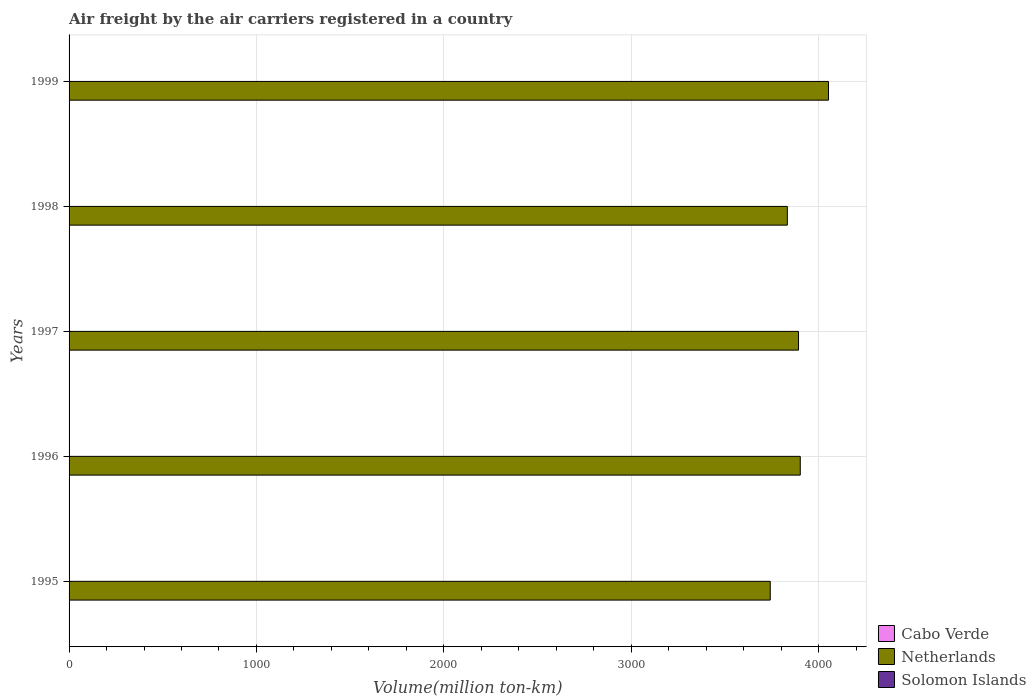How many different coloured bars are there?
Offer a terse response. 3. How many groups of bars are there?
Offer a very short reply. 5. Are the number of bars per tick equal to the number of legend labels?
Your response must be concise. Yes. Are the number of bars on each tick of the Y-axis equal?
Your answer should be very brief. Yes. How many bars are there on the 5th tick from the top?
Your answer should be compact. 3. What is the volume of the air carriers in Netherlands in 1996?
Keep it short and to the point. 3902.4. Across all years, what is the maximum volume of the air carriers in Netherlands?
Offer a terse response. 4053. Across all years, what is the minimum volume of the air carriers in Solomon Islands?
Your answer should be compact. 1.3. In which year was the volume of the air carriers in Solomon Islands minimum?
Provide a succinct answer. 1999. What is the total volume of the air carriers in Cabo Verde in the graph?
Offer a very short reply. 3.2. What is the difference between the volume of the air carriers in Solomon Islands in 1995 and that in 1996?
Offer a very short reply. -0.1. What is the difference between the volume of the air carriers in Netherlands in 1998 and the volume of the air carriers in Cabo Verde in 1999?
Give a very brief answer. 3832.8. What is the average volume of the air carriers in Netherlands per year?
Your response must be concise. 3884.82. In the year 1999, what is the difference between the volume of the air carriers in Solomon Islands and volume of the air carriers in Cabo Verde?
Provide a succinct answer. 0.7. In how many years, is the volume of the air carriers in Solomon Islands greater than 800 million ton-km?
Provide a succinct answer. 0. What is the ratio of the volume of the air carriers in Solomon Islands in 1996 to that in 1998?
Your answer should be compact. 1. Is the difference between the volume of the air carriers in Solomon Islands in 1997 and 1998 greater than the difference between the volume of the air carriers in Cabo Verde in 1997 and 1998?
Offer a terse response. No. What is the difference between the highest and the second highest volume of the air carriers in Netherlands?
Your answer should be compact. 150.6. What is the difference between the highest and the lowest volume of the air carriers in Solomon Islands?
Keep it short and to the point. 0.4. Is the sum of the volume of the air carriers in Netherlands in 1996 and 1998 greater than the maximum volume of the air carriers in Solomon Islands across all years?
Your answer should be very brief. Yes. What does the 2nd bar from the top in 1996 represents?
Give a very brief answer. Netherlands. What does the 2nd bar from the bottom in 1998 represents?
Your answer should be compact. Netherlands. Is it the case that in every year, the sum of the volume of the air carriers in Solomon Islands and volume of the air carriers in Netherlands is greater than the volume of the air carriers in Cabo Verde?
Ensure brevity in your answer.  Yes. What is the title of the graph?
Your response must be concise. Air freight by the air carriers registered in a country. What is the label or title of the X-axis?
Your response must be concise. Volume(million ton-km). What is the label or title of the Y-axis?
Offer a very short reply. Years. What is the Volume(million ton-km) in Cabo Verde in 1995?
Your answer should be compact. 0.8. What is the Volume(million ton-km) in Netherlands in 1995?
Give a very brief answer. 3742.2. What is the Volume(million ton-km) of Solomon Islands in 1995?
Offer a terse response. 1.6. What is the Volume(million ton-km) of Cabo Verde in 1996?
Your answer should be compact. 0.8. What is the Volume(million ton-km) in Netherlands in 1996?
Offer a terse response. 3902.4. What is the Volume(million ton-km) of Solomon Islands in 1996?
Provide a succinct answer. 1.7. What is the Volume(million ton-km) in Cabo Verde in 1997?
Provide a short and direct response. 0.6. What is the Volume(million ton-km) in Netherlands in 1997?
Provide a succinct answer. 3893.1. What is the Volume(million ton-km) in Solomon Islands in 1997?
Your response must be concise. 1.7. What is the Volume(million ton-km) of Cabo Verde in 1998?
Keep it short and to the point. 0.4. What is the Volume(million ton-km) of Netherlands in 1998?
Your answer should be very brief. 3833.4. What is the Volume(million ton-km) in Solomon Islands in 1998?
Provide a short and direct response. 1.7. What is the Volume(million ton-km) in Cabo Verde in 1999?
Provide a succinct answer. 0.6. What is the Volume(million ton-km) in Netherlands in 1999?
Make the answer very short. 4053. What is the Volume(million ton-km) of Solomon Islands in 1999?
Offer a terse response. 1.3. Across all years, what is the maximum Volume(million ton-km) in Cabo Verde?
Your response must be concise. 0.8. Across all years, what is the maximum Volume(million ton-km) in Netherlands?
Provide a short and direct response. 4053. Across all years, what is the maximum Volume(million ton-km) in Solomon Islands?
Keep it short and to the point. 1.7. Across all years, what is the minimum Volume(million ton-km) of Cabo Verde?
Provide a short and direct response. 0.4. Across all years, what is the minimum Volume(million ton-km) of Netherlands?
Offer a terse response. 3742.2. Across all years, what is the minimum Volume(million ton-km) in Solomon Islands?
Your answer should be very brief. 1.3. What is the total Volume(million ton-km) of Netherlands in the graph?
Your answer should be very brief. 1.94e+04. What is the difference between the Volume(million ton-km) of Netherlands in 1995 and that in 1996?
Give a very brief answer. -160.2. What is the difference between the Volume(million ton-km) of Netherlands in 1995 and that in 1997?
Offer a terse response. -150.9. What is the difference between the Volume(million ton-km) of Netherlands in 1995 and that in 1998?
Make the answer very short. -91.2. What is the difference between the Volume(million ton-km) of Solomon Islands in 1995 and that in 1998?
Your answer should be very brief. -0.1. What is the difference between the Volume(million ton-km) in Cabo Verde in 1995 and that in 1999?
Your response must be concise. 0.2. What is the difference between the Volume(million ton-km) of Netherlands in 1995 and that in 1999?
Keep it short and to the point. -310.8. What is the difference between the Volume(million ton-km) of Solomon Islands in 1995 and that in 1999?
Keep it short and to the point. 0.3. What is the difference between the Volume(million ton-km) of Netherlands in 1996 and that in 1997?
Make the answer very short. 9.3. What is the difference between the Volume(million ton-km) in Solomon Islands in 1996 and that in 1997?
Your answer should be very brief. 0. What is the difference between the Volume(million ton-km) in Netherlands in 1996 and that in 1999?
Offer a very short reply. -150.6. What is the difference between the Volume(million ton-km) of Cabo Verde in 1997 and that in 1998?
Provide a succinct answer. 0.2. What is the difference between the Volume(million ton-km) of Netherlands in 1997 and that in 1998?
Provide a short and direct response. 59.7. What is the difference between the Volume(million ton-km) in Solomon Islands in 1997 and that in 1998?
Provide a short and direct response. 0. What is the difference between the Volume(million ton-km) of Netherlands in 1997 and that in 1999?
Keep it short and to the point. -159.9. What is the difference between the Volume(million ton-km) in Netherlands in 1998 and that in 1999?
Keep it short and to the point. -219.6. What is the difference between the Volume(million ton-km) of Solomon Islands in 1998 and that in 1999?
Make the answer very short. 0.4. What is the difference between the Volume(million ton-km) of Cabo Verde in 1995 and the Volume(million ton-km) of Netherlands in 1996?
Provide a succinct answer. -3901.6. What is the difference between the Volume(million ton-km) of Cabo Verde in 1995 and the Volume(million ton-km) of Solomon Islands in 1996?
Provide a short and direct response. -0.9. What is the difference between the Volume(million ton-km) in Netherlands in 1995 and the Volume(million ton-km) in Solomon Islands in 1996?
Offer a very short reply. 3740.5. What is the difference between the Volume(million ton-km) of Cabo Verde in 1995 and the Volume(million ton-km) of Netherlands in 1997?
Offer a very short reply. -3892.3. What is the difference between the Volume(million ton-km) of Cabo Verde in 1995 and the Volume(million ton-km) of Solomon Islands in 1997?
Your answer should be compact. -0.9. What is the difference between the Volume(million ton-km) in Netherlands in 1995 and the Volume(million ton-km) in Solomon Islands in 1997?
Make the answer very short. 3740.5. What is the difference between the Volume(million ton-km) of Cabo Verde in 1995 and the Volume(million ton-km) of Netherlands in 1998?
Give a very brief answer. -3832.6. What is the difference between the Volume(million ton-km) of Cabo Verde in 1995 and the Volume(million ton-km) of Solomon Islands in 1998?
Offer a terse response. -0.9. What is the difference between the Volume(million ton-km) of Netherlands in 1995 and the Volume(million ton-km) of Solomon Islands in 1998?
Provide a short and direct response. 3740.5. What is the difference between the Volume(million ton-km) in Cabo Verde in 1995 and the Volume(million ton-km) in Netherlands in 1999?
Give a very brief answer. -4052.2. What is the difference between the Volume(million ton-km) of Cabo Verde in 1995 and the Volume(million ton-km) of Solomon Islands in 1999?
Offer a very short reply. -0.5. What is the difference between the Volume(million ton-km) of Netherlands in 1995 and the Volume(million ton-km) of Solomon Islands in 1999?
Give a very brief answer. 3740.9. What is the difference between the Volume(million ton-km) of Cabo Verde in 1996 and the Volume(million ton-km) of Netherlands in 1997?
Ensure brevity in your answer.  -3892.3. What is the difference between the Volume(million ton-km) of Netherlands in 1996 and the Volume(million ton-km) of Solomon Islands in 1997?
Give a very brief answer. 3900.7. What is the difference between the Volume(million ton-km) in Cabo Verde in 1996 and the Volume(million ton-km) in Netherlands in 1998?
Offer a very short reply. -3832.6. What is the difference between the Volume(million ton-km) in Netherlands in 1996 and the Volume(million ton-km) in Solomon Islands in 1998?
Ensure brevity in your answer.  3900.7. What is the difference between the Volume(million ton-km) of Cabo Verde in 1996 and the Volume(million ton-km) of Netherlands in 1999?
Provide a succinct answer. -4052.2. What is the difference between the Volume(million ton-km) of Netherlands in 1996 and the Volume(million ton-km) of Solomon Islands in 1999?
Provide a succinct answer. 3901.1. What is the difference between the Volume(million ton-km) of Cabo Verde in 1997 and the Volume(million ton-km) of Netherlands in 1998?
Provide a succinct answer. -3832.8. What is the difference between the Volume(million ton-km) in Cabo Verde in 1997 and the Volume(million ton-km) in Solomon Islands in 1998?
Offer a very short reply. -1.1. What is the difference between the Volume(million ton-km) in Netherlands in 1997 and the Volume(million ton-km) in Solomon Islands in 1998?
Give a very brief answer. 3891.4. What is the difference between the Volume(million ton-km) in Cabo Verde in 1997 and the Volume(million ton-km) in Netherlands in 1999?
Provide a short and direct response. -4052.4. What is the difference between the Volume(million ton-km) in Cabo Verde in 1997 and the Volume(million ton-km) in Solomon Islands in 1999?
Your answer should be very brief. -0.7. What is the difference between the Volume(million ton-km) in Netherlands in 1997 and the Volume(million ton-km) in Solomon Islands in 1999?
Keep it short and to the point. 3891.8. What is the difference between the Volume(million ton-km) of Cabo Verde in 1998 and the Volume(million ton-km) of Netherlands in 1999?
Make the answer very short. -4052.6. What is the difference between the Volume(million ton-km) of Cabo Verde in 1998 and the Volume(million ton-km) of Solomon Islands in 1999?
Provide a short and direct response. -0.9. What is the difference between the Volume(million ton-km) in Netherlands in 1998 and the Volume(million ton-km) in Solomon Islands in 1999?
Give a very brief answer. 3832.1. What is the average Volume(million ton-km) in Cabo Verde per year?
Your response must be concise. 0.64. What is the average Volume(million ton-km) in Netherlands per year?
Provide a short and direct response. 3884.82. In the year 1995, what is the difference between the Volume(million ton-km) of Cabo Verde and Volume(million ton-km) of Netherlands?
Offer a terse response. -3741.4. In the year 1995, what is the difference between the Volume(million ton-km) of Netherlands and Volume(million ton-km) of Solomon Islands?
Keep it short and to the point. 3740.6. In the year 1996, what is the difference between the Volume(million ton-km) in Cabo Verde and Volume(million ton-km) in Netherlands?
Your answer should be very brief. -3901.6. In the year 1996, what is the difference between the Volume(million ton-km) in Netherlands and Volume(million ton-km) in Solomon Islands?
Make the answer very short. 3900.7. In the year 1997, what is the difference between the Volume(million ton-km) of Cabo Verde and Volume(million ton-km) of Netherlands?
Give a very brief answer. -3892.5. In the year 1997, what is the difference between the Volume(million ton-km) of Netherlands and Volume(million ton-km) of Solomon Islands?
Give a very brief answer. 3891.4. In the year 1998, what is the difference between the Volume(million ton-km) in Cabo Verde and Volume(million ton-km) in Netherlands?
Provide a succinct answer. -3833. In the year 1998, what is the difference between the Volume(million ton-km) in Cabo Verde and Volume(million ton-km) in Solomon Islands?
Make the answer very short. -1.3. In the year 1998, what is the difference between the Volume(million ton-km) of Netherlands and Volume(million ton-km) of Solomon Islands?
Make the answer very short. 3831.7. In the year 1999, what is the difference between the Volume(million ton-km) in Cabo Verde and Volume(million ton-km) in Netherlands?
Provide a short and direct response. -4052.4. In the year 1999, what is the difference between the Volume(million ton-km) of Netherlands and Volume(million ton-km) of Solomon Islands?
Your answer should be very brief. 4051.7. What is the ratio of the Volume(million ton-km) in Cabo Verde in 1995 to that in 1996?
Give a very brief answer. 1. What is the ratio of the Volume(million ton-km) of Netherlands in 1995 to that in 1996?
Offer a very short reply. 0.96. What is the ratio of the Volume(million ton-km) of Solomon Islands in 1995 to that in 1996?
Your answer should be very brief. 0.94. What is the ratio of the Volume(million ton-km) in Cabo Verde in 1995 to that in 1997?
Make the answer very short. 1.33. What is the ratio of the Volume(million ton-km) in Netherlands in 1995 to that in 1997?
Offer a very short reply. 0.96. What is the ratio of the Volume(million ton-km) in Solomon Islands in 1995 to that in 1997?
Your response must be concise. 0.94. What is the ratio of the Volume(million ton-km) of Cabo Verde in 1995 to that in 1998?
Make the answer very short. 2. What is the ratio of the Volume(million ton-km) of Netherlands in 1995 to that in 1998?
Offer a terse response. 0.98. What is the ratio of the Volume(million ton-km) of Cabo Verde in 1995 to that in 1999?
Your answer should be very brief. 1.33. What is the ratio of the Volume(million ton-km) of Netherlands in 1995 to that in 1999?
Offer a terse response. 0.92. What is the ratio of the Volume(million ton-km) in Solomon Islands in 1995 to that in 1999?
Keep it short and to the point. 1.23. What is the ratio of the Volume(million ton-km) in Netherlands in 1996 to that in 1998?
Ensure brevity in your answer.  1.02. What is the ratio of the Volume(million ton-km) of Cabo Verde in 1996 to that in 1999?
Your answer should be very brief. 1.33. What is the ratio of the Volume(million ton-km) in Netherlands in 1996 to that in 1999?
Your answer should be very brief. 0.96. What is the ratio of the Volume(million ton-km) in Solomon Islands in 1996 to that in 1999?
Offer a terse response. 1.31. What is the ratio of the Volume(million ton-km) in Netherlands in 1997 to that in 1998?
Make the answer very short. 1.02. What is the ratio of the Volume(million ton-km) in Netherlands in 1997 to that in 1999?
Your answer should be very brief. 0.96. What is the ratio of the Volume(million ton-km) in Solomon Islands in 1997 to that in 1999?
Keep it short and to the point. 1.31. What is the ratio of the Volume(million ton-km) of Cabo Verde in 1998 to that in 1999?
Provide a succinct answer. 0.67. What is the ratio of the Volume(million ton-km) in Netherlands in 1998 to that in 1999?
Your answer should be compact. 0.95. What is the ratio of the Volume(million ton-km) of Solomon Islands in 1998 to that in 1999?
Your answer should be compact. 1.31. What is the difference between the highest and the second highest Volume(million ton-km) in Netherlands?
Give a very brief answer. 150.6. What is the difference between the highest and the second highest Volume(million ton-km) of Solomon Islands?
Ensure brevity in your answer.  0. What is the difference between the highest and the lowest Volume(million ton-km) in Netherlands?
Your answer should be compact. 310.8. 